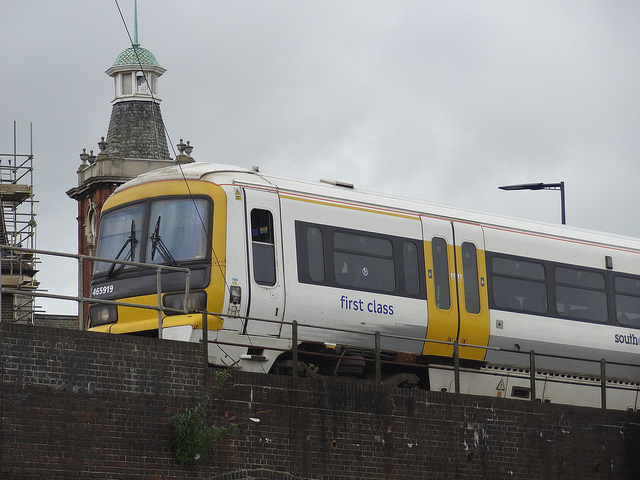Please extract the text content from this image. 465919 first class south 